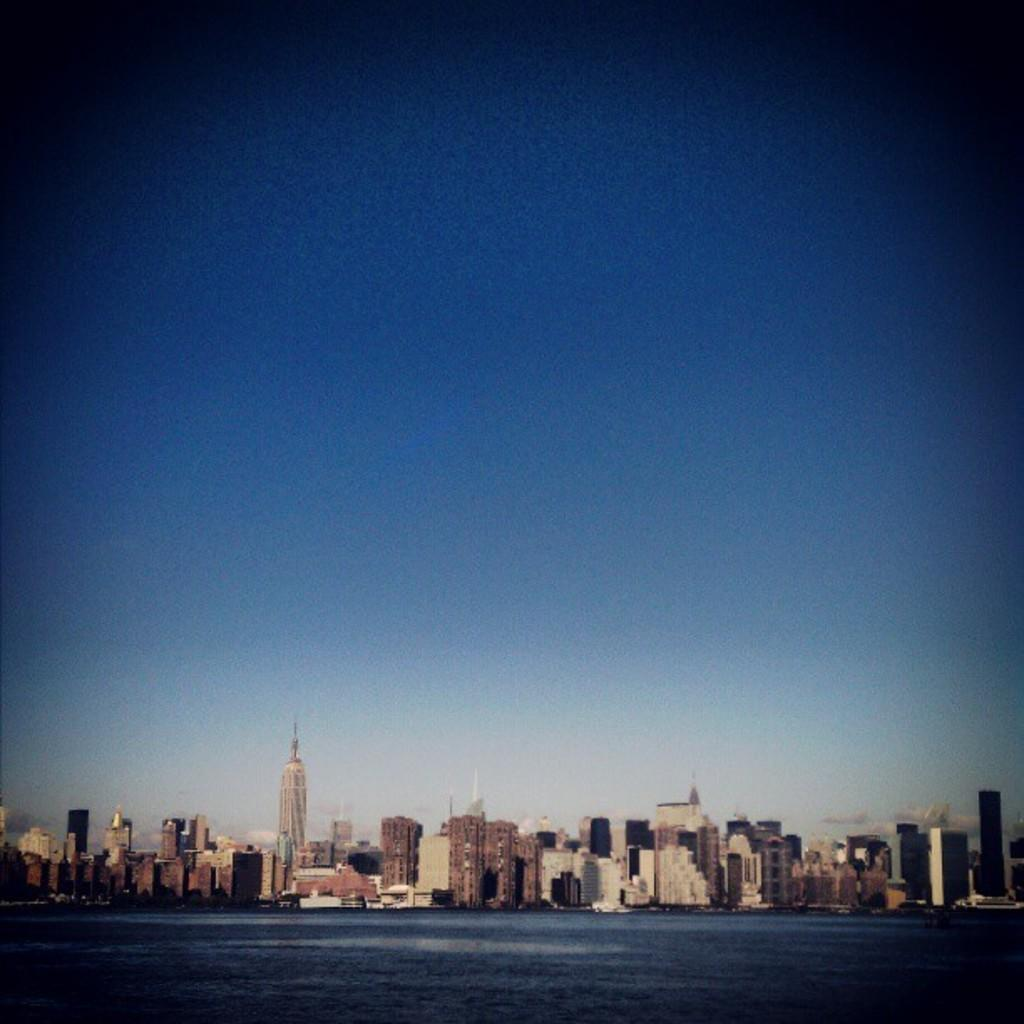What type of structures can be seen in the image? There are buildings in the image. What natural element is visible at the bottom of the image? There is water visible at the bottom of the image. What part of the natural environment is visible at the top of the image? The sky is visible at the top of the image. What type of dress is being worn by the water in the image? There is no dress present in the image, as the water is a natural element and not a person wearing clothing. 